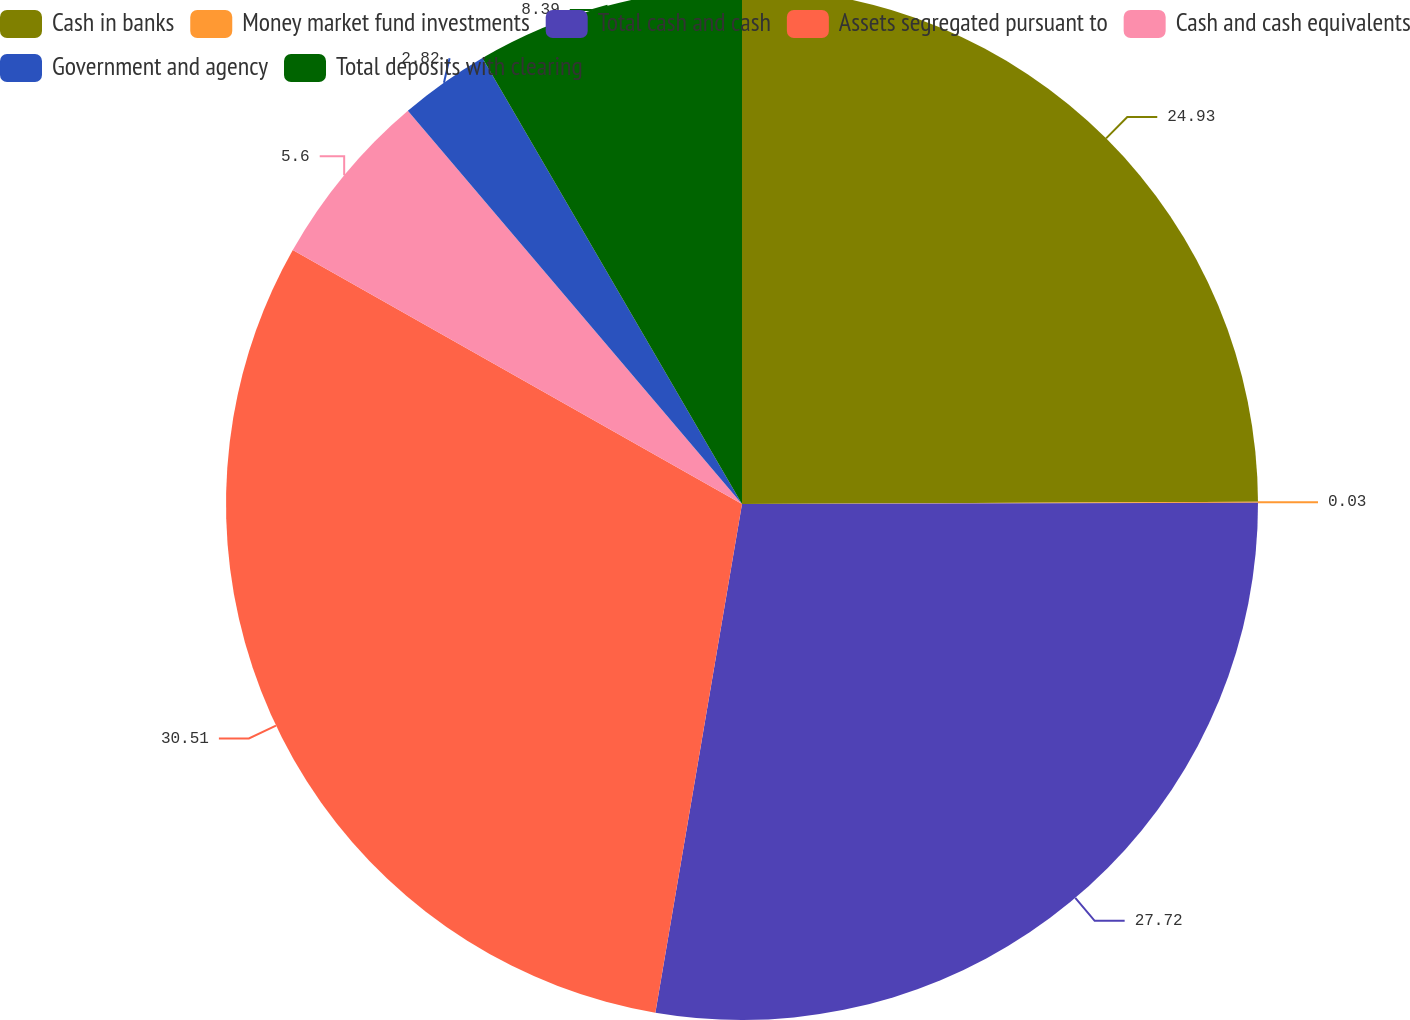Convert chart. <chart><loc_0><loc_0><loc_500><loc_500><pie_chart><fcel>Cash in banks<fcel>Money market fund investments<fcel>Total cash and cash<fcel>Assets segregated pursuant to<fcel>Cash and cash equivalents<fcel>Government and agency<fcel>Total deposits with clearing<nl><fcel>24.93%<fcel>0.03%<fcel>27.72%<fcel>30.5%<fcel>5.6%<fcel>2.82%<fcel>8.39%<nl></chart> 